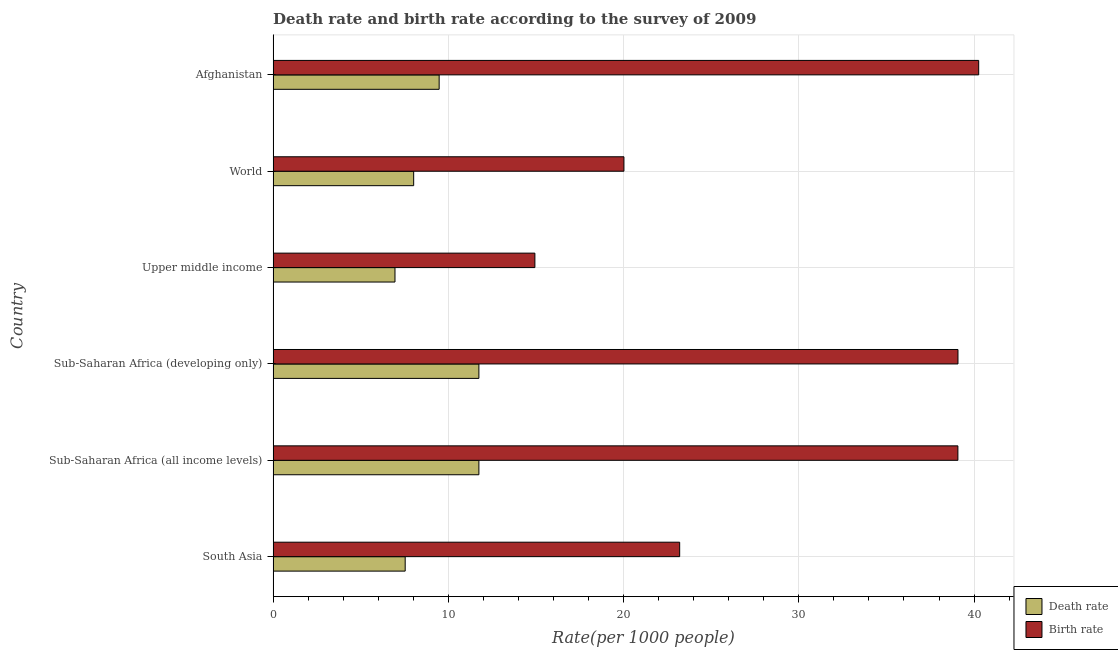How many groups of bars are there?
Give a very brief answer. 6. Are the number of bars per tick equal to the number of legend labels?
Keep it short and to the point. Yes. What is the label of the 3rd group of bars from the top?
Ensure brevity in your answer.  Upper middle income. What is the death rate in South Asia?
Ensure brevity in your answer.  7.54. Across all countries, what is the maximum birth rate?
Make the answer very short. 40.27. Across all countries, what is the minimum death rate?
Your response must be concise. 6.95. In which country was the death rate maximum?
Offer a terse response. Sub-Saharan Africa (developing only). In which country was the death rate minimum?
Your answer should be very brief. Upper middle income. What is the total death rate in the graph?
Provide a short and direct response. 55.47. What is the difference between the death rate in South Asia and that in Upper middle income?
Provide a short and direct response. 0.58. What is the difference between the death rate in South Asia and the birth rate in Upper middle income?
Offer a terse response. -7.4. What is the average birth rate per country?
Provide a succinct answer. 29.43. In how many countries, is the death rate greater than 40 ?
Provide a succinct answer. 0. What is the ratio of the birth rate in Afghanistan to that in Sub-Saharan Africa (developing only)?
Keep it short and to the point. 1.03. Is the death rate in Afghanistan less than that in Sub-Saharan Africa (developing only)?
Make the answer very short. Yes. Is the difference between the birth rate in Afghanistan and South Asia greater than the difference between the death rate in Afghanistan and South Asia?
Offer a terse response. Yes. What is the difference between the highest and the second highest birth rate?
Provide a short and direct response. 1.18. What is the difference between the highest and the lowest birth rate?
Provide a short and direct response. 25.33. Is the sum of the death rate in South Asia and Upper middle income greater than the maximum birth rate across all countries?
Ensure brevity in your answer.  No. What does the 2nd bar from the top in World represents?
Provide a short and direct response. Death rate. What does the 2nd bar from the bottom in South Asia represents?
Make the answer very short. Birth rate. Are the values on the major ticks of X-axis written in scientific E-notation?
Your answer should be very brief. No. Does the graph contain grids?
Ensure brevity in your answer.  Yes. How many legend labels are there?
Keep it short and to the point. 2. How are the legend labels stacked?
Provide a short and direct response. Vertical. What is the title of the graph?
Provide a succinct answer. Death rate and birth rate according to the survey of 2009. Does "Mineral" appear as one of the legend labels in the graph?
Give a very brief answer. No. What is the label or title of the X-axis?
Your answer should be compact. Rate(per 1000 people). What is the Rate(per 1000 people) of Death rate in South Asia?
Your response must be concise. 7.54. What is the Rate(per 1000 people) in Birth rate in South Asia?
Provide a succinct answer. 23.2. What is the Rate(per 1000 people) in Death rate in Sub-Saharan Africa (all income levels)?
Give a very brief answer. 11.74. What is the Rate(per 1000 people) of Birth rate in Sub-Saharan Africa (all income levels)?
Provide a short and direct response. 39.08. What is the Rate(per 1000 people) of Death rate in Sub-Saharan Africa (developing only)?
Offer a terse response. 11.74. What is the Rate(per 1000 people) of Birth rate in Sub-Saharan Africa (developing only)?
Your answer should be very brief. 39.08. What is the Rate(per 1000 people) in Death rate in Upper middle income?
Make the answer very short. 6.95. What is the Rate(per 1000 people) in Birth rate in Upper middle income?
Give a very brief answer. 14.94. What is the Rate(per 1000 people) in Death rate in World?
Provide a succinct answer. 8.02. What is the Rate(per 1000 people) in Birth rate in World?
Ensure brevity in your answer.  20.02. What is the Rate(per 1000 people) in Death rate in Afghanistan?
Ensure brevity in your answer.  9.47. What is the Rate(per 1000 people) of Birth rate in Afghanistan?
Ensure brevity in your answer.  40.27. Across all countries, what is the maximum Rate(per 1000 people) of Death rate?
Ensure brevity in your answer.  11.74. Across all countries, what is the maximum Rate(per 1000 people) of Birth rate?
Ensure brevity in your answer.  40.27. Across all countries, what is the minimum Rate(per 1000 people) of Death rate?
Give a very brief answer. 6.95. Across all countries, what is the minimum Rate(per 1000 people) of Birth rate?
Your response must be concise. 14.94. What is the total Rate(per 1000 people) in Death rate in the graph?
Provide a short and direct response. 55.47. What is the total Rate(per 1000 people) of Birth rate in the graph?
Offer a terse response. 176.59. What is the difference between the Rate(per 1000 people) of Death rate in South Asia and that in Sub-Saharan Africa (all income levels)?
Offer a very short reply. -4.21. What is the difference between the Rate(per 1000 people) in Birth rate in South Asia and that in Sub-Saharan Africa (all income levels)?
Provide a succinct answer. -15.88. What is the difference between the Rate(per 1000 people) of Death rate in South Asia and that in Sub-Saharan Africa (developing only)?
Provide a short and direct response. -4.21. What is the difference between the Rate(per 1000 people) in Birth rate in South Asia and that in Sub-Saharan Africa (developing only)?
Ensure brevity in your answer.  -15.88. What is the difference between the Rate(per 1000 people) of Death rate in South Asia and that in Upper middle income?
Your response must be concise. 0.58. What is the difference between the Rate(per 1000 people) in Birth rate in South Asia and that in Upper middle income?
Offer a terse response. 8.26. What is the difference between the Rate(per 1000 people) in Death rate in South Asia and that in World?
Your answer should be compact. -0.48. What is the difference between the Rate(per 1000 people) of Birth rate in South Asia and that in World?
Offer a very short reply. 3.18. What is the difference between the Rate(per 1000 people) of Death rate in South Asia and that in Afghanistan?
Make the answer very short. -1.94. What is the difference between the Rate(per 1000 people) of Birth rate in South Asia and that in Afghanistan?
Make the answer very short. -17.06. What is the difference between the Rate(per 1000 people) in Death rate in Sub-Saharan Africa (all income levels) and that in Sub-Saharan Africa (developing only)?
Make the answer very short. -0. What is the difference between the Rate(per 1000 people) of Birth rate in Sub-Saharan Africa (all income levels) and that in Sub-Saharan Africa (developing only)?
Provide a short and direct response. -0. What is the difference between the Rate(per 1000 people) in Death rate in Sub-Saharan Africa (all income levels) and that in Upper middle income?
Provide a succinct answer. 4.79. What is the difference between the Rate(per 1000 people) of Birth rate in Sub-Saharan Africa (all income levels) and that in Upper middle income?
Your answer should be compact. 24.14. What is the difference between the Rate(per 1000 people) in Death rate in Sub-Saharan Africa (all income levels) and that in World?
Your response must be concise. 3.72. What is the difference between the Rate(per 1000 people) of Birth rate in Sub-Saharan Africa (all income levels) and that in World?
Make the answer very short. 19.06. What is the difference between the Rate(per 1000 people) in Death rate in Sub-Saharan Africa (all income levels) and that in Afghanistan?
Your answer should be very brief. 2.27. What is the difference between the Rate(per 1000 people) in Birth rate in Sub-Saharan Africa (all income levels) and that in Afghanistan?
Your response must be concise. -1.19. What is the difference between the Rate(per 1000 people) in Death rate in Sub-Saharan Africa (developing only) and that in Upper middle income?
Provide a short and direct response. 4.79. What is the difference between the Rate(per 1000 people) of Birth rate in Sub-Saharan Africa (developing only) and that in Upper middle income?
Provide a succinct answer. 24.14. What is the difference between the Rate(per 1000 people) of Death rate in Sub-Saharan Africa (developing only) and that in World?
Your response must be concise. 3.72. What is the difference between the Rate(per 1000 people) in Birth rate in Sub-Saharan Africa (developing only) and that in World?
Your answer should be compact. 19.06. What is the difference between the Rate(per 1000 people) in Death rate in Sub-Saharan Africa (developing only) and that in Afghanistan?
Offer a very short reply. 2.27. What is the difference between the Rate(per 1000 people) in Birth rate in Sub-Saharan Africa (developing only) and that in Afghanistan?
Offer a terse response. -1.18. What is the difference between the Rate(per 1000 people) of Death rate in Upper middle income and that in World?
Make the answer very short. -1.07. What is the difference between the Rate(per 1000 people) of Birth rate in Upper middle income and that in World?
Your answer should be compact. -5.08. What is the difference between the Rate(per 1000 people) in Death rate in Upper middle income and that in Afghanistan?
Make the answer very short. -2.52. What is the difference between the Rate(per 1000 people) of Birth rate in Upper middle income and that in Afghanistan?
Provide a succinct answer. -25.33. What is the difference between the Rate(per 1000 people) of Death rate in World and that in Afghanistan?
Your response must be concise. -1.45. What is the difference between the Rate(per 1000 people) of Birth rate in World and that in Afghanistan?
Make the answer very short. -20.24. What is the difference between the Rate(per 1000 people) of Death rate in South Asia and the Rate(per 1000 people) of Birth rate in Sub-Saharan Africa (all income levels)?
Give a very brief answer. -31.54. What is the difference between the Rate(per 1000 people) in Death rate in South Asia and the Rate(per 1000 people) in Birth rate in Sub-Saharan Africa (developing only)?
Provide a succinct answer. -31.55. What is the difference between the Rate(per 1000 people) of Death rate in South Asia and the Rate(per 1000 people) of Birth rate in Upper middle income?
Ensure brevity in your answer.  -7.4. What is the difference between the Rate(per 1000 people) in Death rate in South Asia and the Rate(per 1000 people) in Birth rate in World?
Your answer should be very brief. -12.48. What is the difference between the Rate(per 1000 people) of Death rate in South Asia and the Rate(per 1000 people) of Birth rate in Afghanistan?
Make the answer very short. -32.73. What is the difference between the Rate(per 1000 people) of Death rate in Sub-Saharan Africa (all income levels) and the Rate(per 1000 people) of Birth rate in Sub-Saharan Africa (developing only)?
Ensure brevity in your answer.  -27.34. What is the difference between the Rate(per 1000 people) in Death rate in Sub-Saharan Africa (all income levels) and the Rate(per 1000 people) in Birth rate in Upper middle income?
Provide a short and direct response. -3.2. What is the difference between the Rate(per 1000 people) in Death rate in Sub-Saharan Africa (all income levels) and the Rate(per 1000 people) in Birth rate in World?
Your response must be concise. -8.28. What is the difference between the Rate(per 1000 people) in Death rate in Sub-Saharan Africa (all income levels) and the Rate(per 1000 people) in Birth rate in Afghanistan?
Keep it short and to the point. -28.52. What is the difference between the Rate(per 1000 people) in Death rate in Sub-Saharan Africa (developing only) and the Rate(per 1000 people) in Birth rate in Upper middle income?
Offer a terse response. -3.2. What is the difference between the Rate(per 1000 people) in Death rate in Sub-Saharan Africa (developing only) and the Rate(per 1000 people) in Birth rate in World?
Your answer should be very brief. -8.28. What is the difference between the Rate(per 1000 people) in Death rate in Sub-Saharan Africa (developing only) and the Rate(per 1000 people) in Birth rate in Afghanistan?
Give a very brief answer. -28.52. What is the difference between the Rate(per 1000 people) in Death rate in Upper middle income and the Rate(per 1000 people) in Birth rate in World?
Your answer should be very brief. -13.07. What is the difference between the Rate(per 1000 people) of Death rate in Upper middle income and the Rate(per 1000 people) of Birth rate in Afghanistan?
Your answer should be compact. -33.31. What is the difference between the Rate(per 1000 people) of Death rate in World and the Rate(per 1000 people) of Birth rate in Afghanistan?
Keep it short and to the point. -32.24. What is the average Rate(per 1000 people) in Death rate per country?
Provide a succinct answer. 9.25. What is the average Rate(per 1000 people) in Birth rate per country?
Offer a terse response. 29.43. What is the difference between the Rate(per 1000 people) in Death rate and Rate(per 1000 people) in Birth rate in South Asia?
Your answer should be very brief. -15.66. What is the difference between the Rate(per 1000 people) of Death rate and Rate(per 1000 people) of Birth rate in Sub-Saharan Africa (all income levels)?
Offer a terse response. -27.34. What is the difference between the Rate(per 1000 people) of Death rate and Rate(per 1000 people) of Birth rate in Sub-Saharan Africa (developing only)?
Provide a succinct answer. -27.34. What is the difference between the Rate(per 1000 people) of Death rate and Rate(per 1000 people) of Birth rate in Upper middle income?
Offer a terse response. -7.98. What is the difference between the Rate(per 1000 people) of Death rate and Rate(per 1000 people) of Birth rate in World?
Give a very brief answer. -12. What is the difference between the Rate(per 1000 people) of Death rate and Rate(per 1000 people) of Birth rate in Afghanistan?
Your answer should be very brief. -30.79. What is the ratio of the Rate(per 1000 people) in Death rate in South Asia to that in Sub-Saharan Africa (all income levels)?
Offer a terse response. 0.64. What is the ratio of the Rate(per 1000 people) in Birth rate in South Asia to that in Sub-Saharan Africa (all income levels)?
Your answer should be very brief. 0.59. What is the ratio of the Rate(per 1000 people) of Death rate in South Asia to that in Sub-Saharan Africa (developing only)?
Give a very brief answer. 0.64. What is the ratio of the Rate(per 1000 people) of Birth rate in South Asia to that in Sub-Saharan Africa (developing only)?
Make the answer very short. 0.59. What is the ratio of the Rate(per 1000 people) in Death rate in South Asia to that in Upper middle income?
Keep it short and to the point. 1.08. What is the ratio of the Rate(per 1000 people) in Birth rate in South Asia to that in Upper middle income?
Give a very brief answer. 1.55. What is the ratio of the Rate(per 1000 people) of Death rate in South Asia to that in World?
Make the answer very short. 0.94. What is the ratio of the Rate(per 1000 people) of Birth rate in South Asia to that in World?
Provide a short and direct response. 1.16. What is the ratio of the Rate(per 1000 people) of Death rate in South Asia to that in Afghanistan?
Your response must be concise. 0.8. What is the ratio of the Rate(per 1000 people) in Birth rate in South Asia to that in Afghanistan?
Offer a terse response. 0.58. What is the ratio of the Rate(per 1000 people) in Death rate in Sub-Saharan Africa (all income levels) to that in Upper middle income?
Provide a succinct answer. 1.69. What is the ratio of the Rate(per 1000 people) in Birth rate in Sub-Saharan Africa (all income levels) to that in Upper middle income?
Your response must be concise. 2.62. What is the ratio of the Rate(per 1000 people) in Death rate in Sub-Saharan Africa (all income levels) to that in World?
Provide a short and direct response. 1.46. What is the ratio of the Rate(per 1000 people) in Birth rate in Sub-Saharan Africa (all income levels) to that in World?
Your response must be concise. 1.95. What is the ratio of the Rate(per 1000 people) in Death rate in Sub-Saharan Africa (all income levels) to that in Afghanistan?
Your response must be concise. 1.24. What is the ratio of the Rate(per 1000 people) of Birth rate in Sub-Saharan Africa (all income levels) to that in Afghanistan?
Ensure brevity in your answer.  0.97. What is the ratio of the Rate(per 1000 people) of Death rate in Sub-Saharan Africa (developing only) to that in Upper middle income?
Provide a short and direct response. 1.69. What is the ratio of the Rate(per 1000 people) of Birth rate in Sub-Saharan Africa (developing only) to that in Upper middle income?
Provide a succinct answer. 2.62. What is the ratio of the Rate(per 1000 people) in Death rate in Sub-Saharan Africa (developing only) to that in World?
Make the answer very short. 1.46. What is the ratio of the Rate(per 1000 people) in Birth rate in Sub-Saharan Africa (developing only) to that in World?
Provide a short and direct response. 1.95. What is the ratio of the Rate(per 1000 people) in Death rate in Sub-Saharan Africa (developing only) to that in Afghanistan?
Keep it short and to the point. 1.24. What is the ratio of the Rate(per 1000 people) of Birth rate in Sub-Saharan Africa (developing only) to that in Afghanistan?
Ensure brevity in your answer.  0.97. What is the ratio of the Rate(per 1000 people) of Death rate in Upper middle income to that in World?
Offer a very short reply. 0.87. What is the ratio of the Rate(per 1000 people) of Birth rate in Upper middle income to that in World?
Your answer should be very brief. 0.75. What is the ratio of the Rate(per 1000 people) in Death rate in Upper middle income to that in Afghanistan?
Ensure brevity in your answer.  0.73. What is the ratio of the Rate(per 1000 people) of Birth rate in Upper middle income to that in Afghanistan?
Your answer should be compact. 0.37. What is the ratio of the Rate(per 1000 people) in Death rate in World to that in Afghanistan?
Offer a very short reply. 0.85. What is the ratio of the Rate(per 1000 people) in Birth rate in World to that in Afghanistan?
Ensure brevity in your answer.  0.5. What is the difference between the highest and the second highest Rate(per 1000 people) of Birth rate?
Ensure brevity in your answer.  1.18. What is the difference between the highest and the lowest Rate(per 1000 people) of Death rate?
Offer a very short reply. 4.79. What is the difference between the highest and the lowest Rate(per 1000 people) in Birth rate?
Your answer should be very brief. 25.33. 